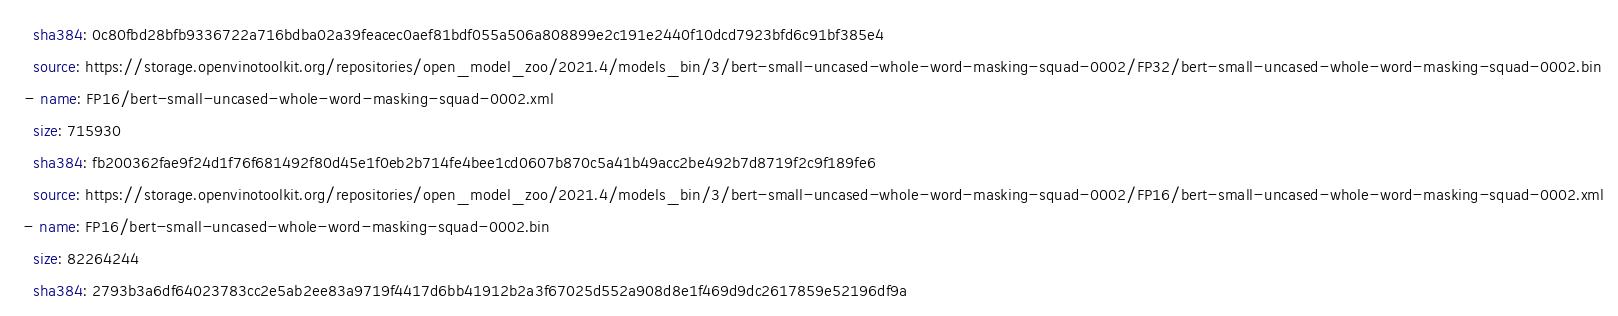<code> <loc_0><loc_0><loc_500><loc_500><_YAML_>    sha384: 0c80fbd28bfb9336722a716bdba02a39feacec0aef81bdf055a506a808899e2c191e2440f10dcd7923bfd6c91bf385e4
    source: https://storage.openvinotoolkit.org/repositories/open_model_zoo/2021.4/models_bin/3/bert-small-uncased-whole-word-masking-squad-0002/FP32/bert-small-uncased-whole-word-masking-squad-0002.bin
  - name: FP16/bert-small-uncased-whole-word-masking-squad-0002.xml
    size: 715930
    sha384: fb200362fae9f24d1f76f681492f80d45e1f0eb2b714fe4bee1cd0607b870c5a41b49acc2be492b7d8719f2c9f189fe6
    source: https://storage.openvinotoolkit.org/repositories/open_model_zoo/2021.4/models_bin/3/bert-small-uncased-whole-word-masking-squad-0002/FP16/bert-small-uncased-whole-word-masking-squad-0002.xml
  - name: FP16/bert-small-uncased-whole-word-masking-squad-0002.bin
    size: 82264244
    sha384: 2793b3a6df64023783cc2e5ab2ee83a9719f4417d6bb41912b2a3f67025d552a908d8e1f469d9dc2617859e52196df9a</code> 